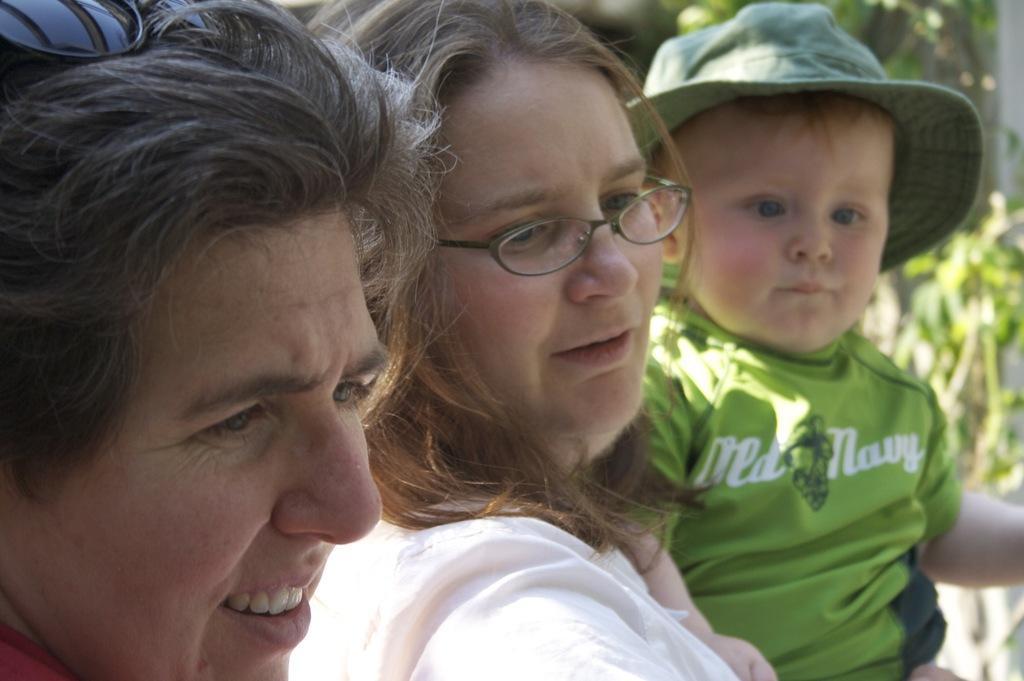Can you describe this image briefly? In this picture I can see two persons with spectacles, there is a boy with a hat, and there is blur background. 